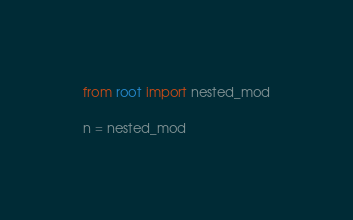Convert code to text. <code><loc_0><loc_0><loc_500><loc_500><_Python_>from root import nested_mod

n = nested_mod</code> 